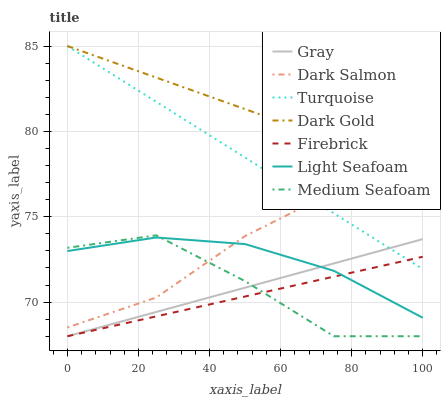Does Firebrick have the minimum area under the curve?
Answer yes or no. Yes. Does Dark Gold have the maximum area under the curve?
Answer yes or no. Yes. Does Turquoise have the minimum area under the curve?
Answer yes or no. No. Does Turquoise have the maximum area under the curve?
Answer yes or no. No. Is Turquoise the smoothest?
Answer yes or no. Yes. Is Medium Seafoam the roughest?
Answer yes or no. Yes. Is Dark Gold the smoothest?
Answer yes or no. No. Is Dark Gold the roughest?
Answer yes or no. No. Does Gray have the lowest value?
Answer yes or no. Yes. Does Turquoise have the lowest value?
Answer yes or no. No. Does Dark Gold have the highest value?
Answer yes or no. Yes. Does Firebrick have the highest value?
Answer yes or no. No. Is Firebrick less than Dark Salmon?
Answer yes or no. Yes. Is Turquoise greater than Medium Seafoam?
Answer yes or no. Yes. Does Firebrick intersect Medium Seafoam?
Answer yes or no. Yes. Is Firebrick less than Medium Seafoam?
Answer yes or no. No. Is Firebrick greater than Medium Seafoam?
Answer yes or no. No. Does Firebrick intersect Dark Salmon?
Answer yes or no. No. 